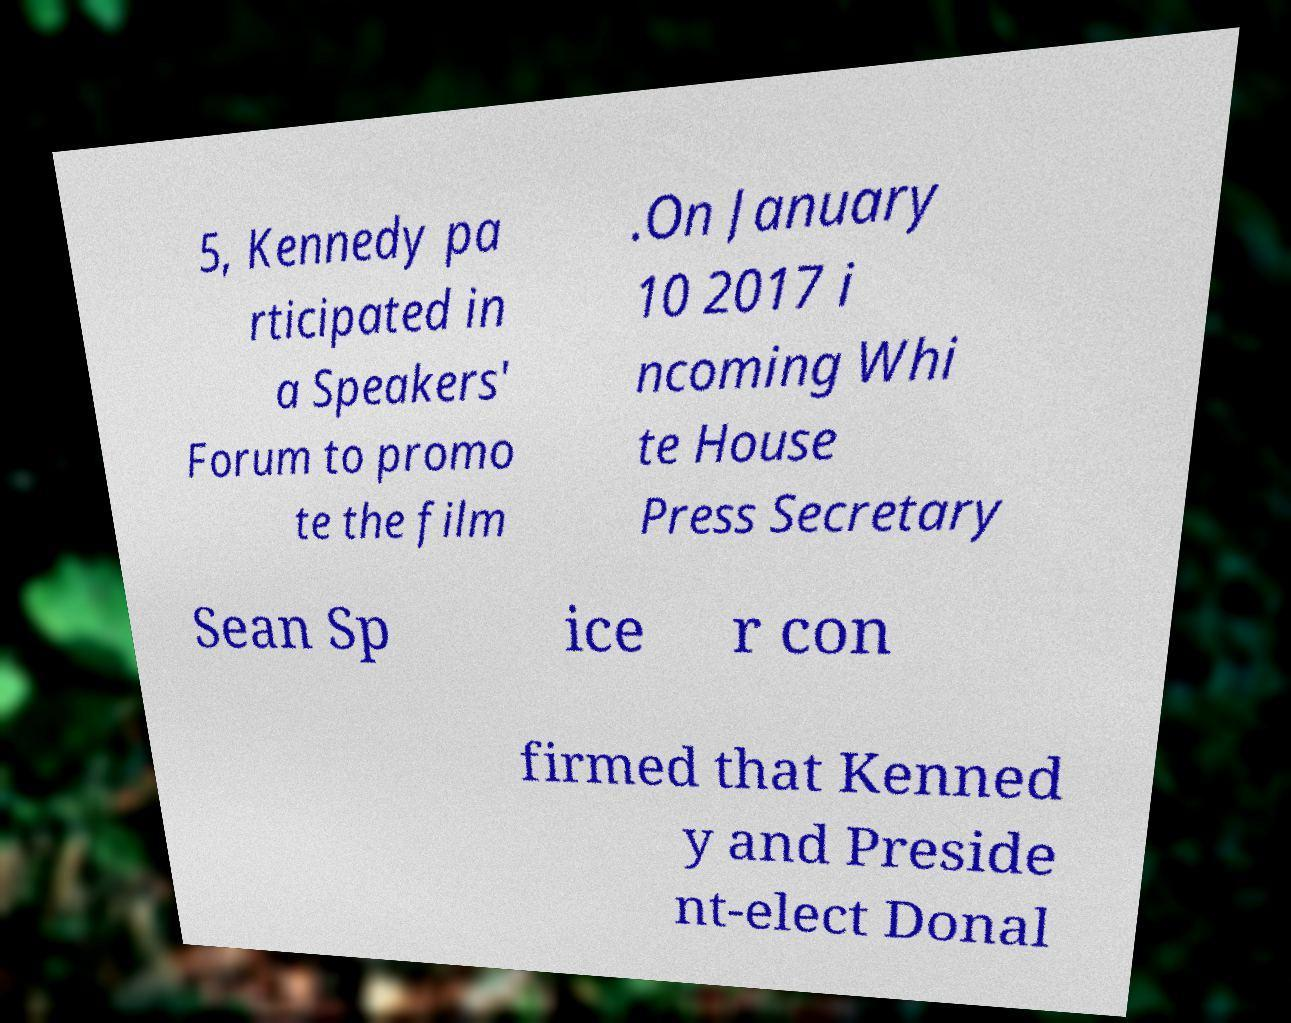Can you accurately transcribe the text from the provided image for me? 5, Kennedy pa rticipated in a Speakers' Forum to promo te the film .On January 10 2017 i ncoming Whi te House Press Secretary Sean Sp ice r con firmed that Kenned y and Preside nt-elect Donal 